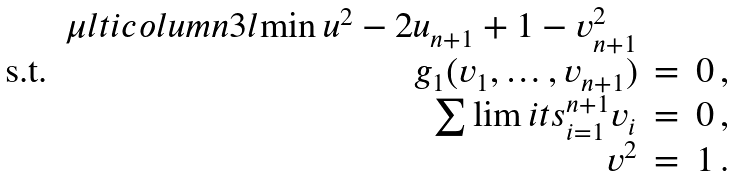Convert formula to latex. <formula><loc_0><loc_0><loc_500><loc_500>\begin{array} { r r c l } & \mu l t i c o l u m n { 3 } { l } { \min u ^ { 2 } - 2 u _ { n + 1 } + 1 - v _ { n + 1 } ^ { 2 } } \\ \text {s.t.} & g _ { 1 } ( v _ { 1 } , \dots , v _ { n + 1 } ) & = & 0 \, , \\ & \sum \lim i t s _ { i = 1 } ^ { n + 1 } v _ { i } & = & 0 \, , \\ & v ^ { 2 } & = & 1 \, . \end{array}</formula> 